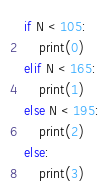Convert code to text. <code><loc_0><loc_0><loc_500><loc_500><_Python_>if N < 105:
    print(0)
elif N < 165:
    print(1)
else N < 195:
    print(2)
else:
    print(3)</code> 